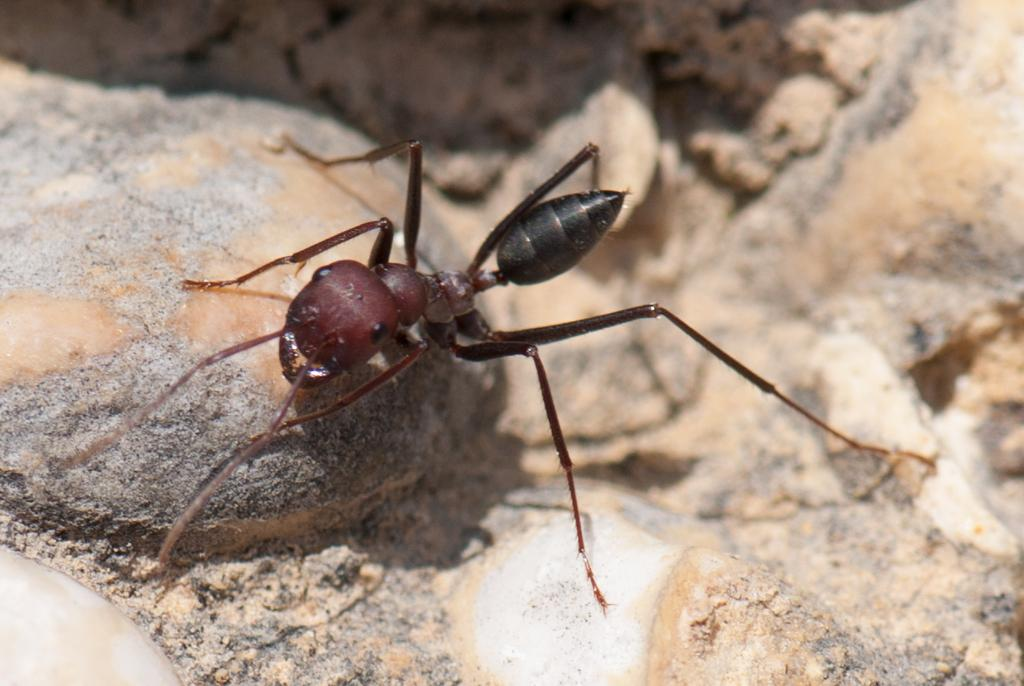What type of small insect is present in the image? There is an ant in the image. What can be seen in the background of the image? There are stones in the background of the image. How many apples are hanging from the string in the image? There are no apples or string present in the image. What type of toy can be seen in the image? There is no toy present in the image. 